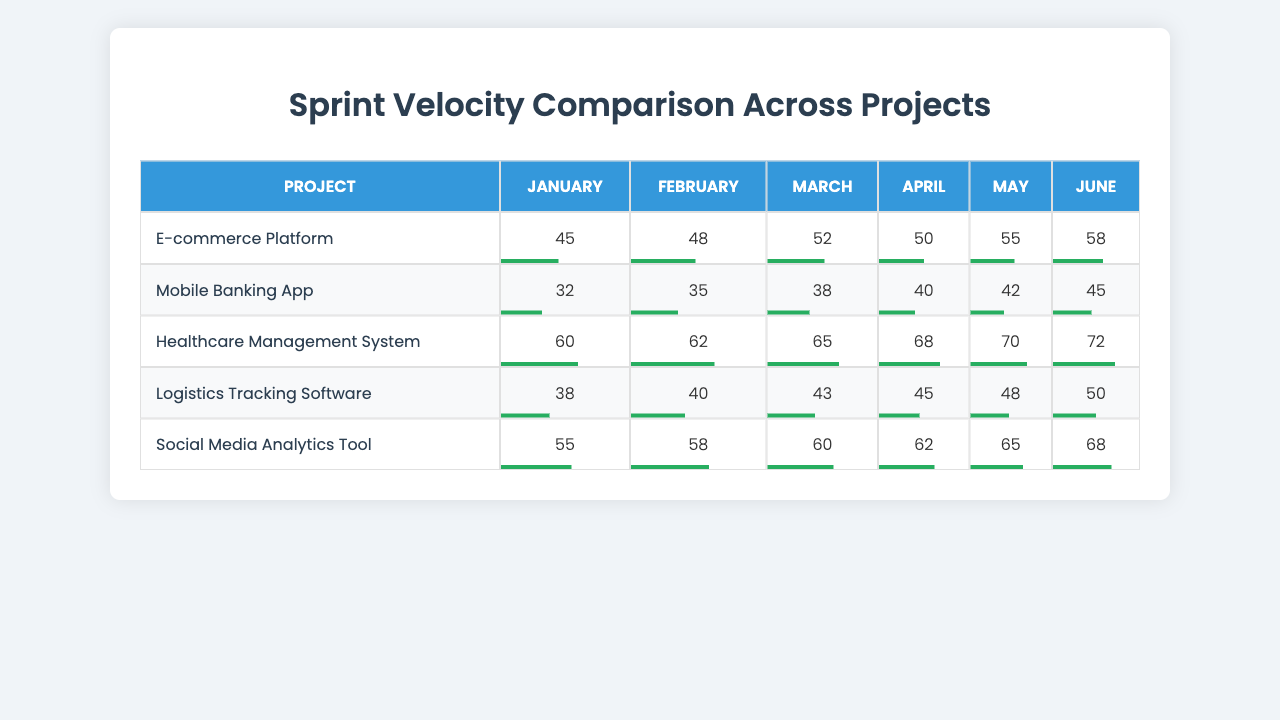What is the sprint velocity of the Healthcare Management System in April? Looking at the table, we find the Healthcare Management System row and the column for April. The value in that cell is 68.
Answer: 68 Which project had the highest sprint velocity in June? In the June column, the velocities are 58, 45, 72, 50, and 68 for each project respectively. The highest value is 72 for the Healthcare Management System.
Answer: Healthcare Management System What was the average sprint velocity for the Mobile Banking App over the six months? To find the average, we add the velocities for each month: 32 + 35 + 38 + 40 + 42 + 45 = 232. Then divide by the number of months, which is 6: 232 / 6 = approximately 38.67.
Answer: 38.67 Did the Social Media Analytics Tool show an increase in sprint velocity every month? We examine the velocities for the Social Media Analytics Tool: 55, 58, 60, 62, 65, and 68. Each subsequent value is greater than the previous value, indicating continuous increase.
Answer: Yes What is the difference in sprint velocity between the E-commerce Platform and the Logistics Tracking Software in May? For May, the E-commerce Platform has a velocity of 55 and the Logistics Tracking Software has 48. Therefore, the difference is 55 - 48 = 7.
Answer: 7 Which project had the lowest overall average sprint velocity? We calculate the average velocities for each project: E-commerce Platform (49.67), Mobile Banking App (38.67), Healthcare Management System (65), Logistics Tracking Software (44), and Social Media Analytics Tool (62.33). The lowest average is for the Mobile Banking App.
Answer: Mobile Banking App How much greater was the average velocity of the Healthcare Management System compared to the E-commerce Platform? The average for the Healthcare Management System is (60 + 62 + 65 + 68 + 70 + 72) / 6 = 66.17 and for the E-commerce Platform is (45 + 48 + 52 + 50 + 55 + 58) / 6 = 49.67. The difference is 66.17 - 49.67 = 16.5.
Answer: 16.5 In which month did the Logistics Tracking Software achieve its highest sprint velocity? Looking at the velocities for the Logistics Tracking Software: 38, 40, 43, 45, 48, 50, the highest value is 50 in June.
Answer: June What was the total sprint velocity for the E-commerce Platform over the six months? The total is found by adding all monthly values: 45 + 48 + 52 + 50 + 55 + 58 = 308.
Answer: 308 